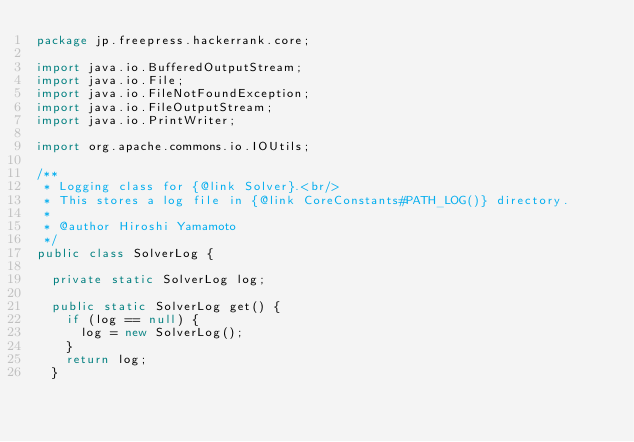Convert code to text. <code><loc_0><loc_0><loc_500><loc_500><_Java_>package jp.freepress.hackerrank.core;

import java.io.BufferedOutputStream;
import java.io.File;
import java.io.FileNotFoundException;
import java.io.FileOutputStream;
import java.io.PrintWriter;

import org.apache.commons.io.IOUtils;

/**
 * Logging class for {@link Solver}.<br/>
 * This stores a log file in {@link CoreConstants#PATH_LOG()} directory.
 * 
 * @author Hiroshi Yamamoto
 */
public class SolverLog {

  private static SolverLog log;

  public static SolverLog get() {
    if (log == null) {
      log = new SolverLog();
    }
    return log;
  }
</code> 